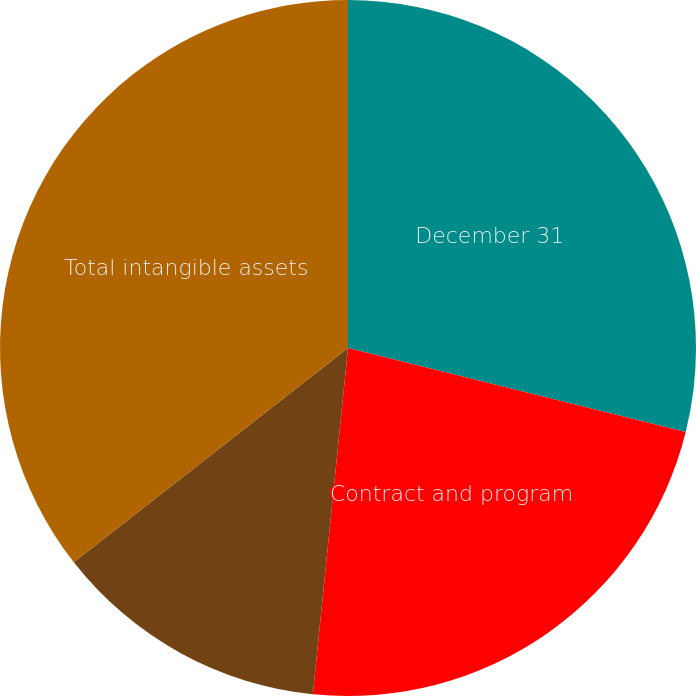Convert chart. <chart><loc_0><loc_0><loc_500><loc_500><pie_chart><fcel>December 31<fcel>Contract and program<fcel>Other intangible assets<fcel>Total intangible assets<nl><fcel>28.88%<fcel>22.73%<fcel>12.83%<fcel>35.56%<nl></chart> 